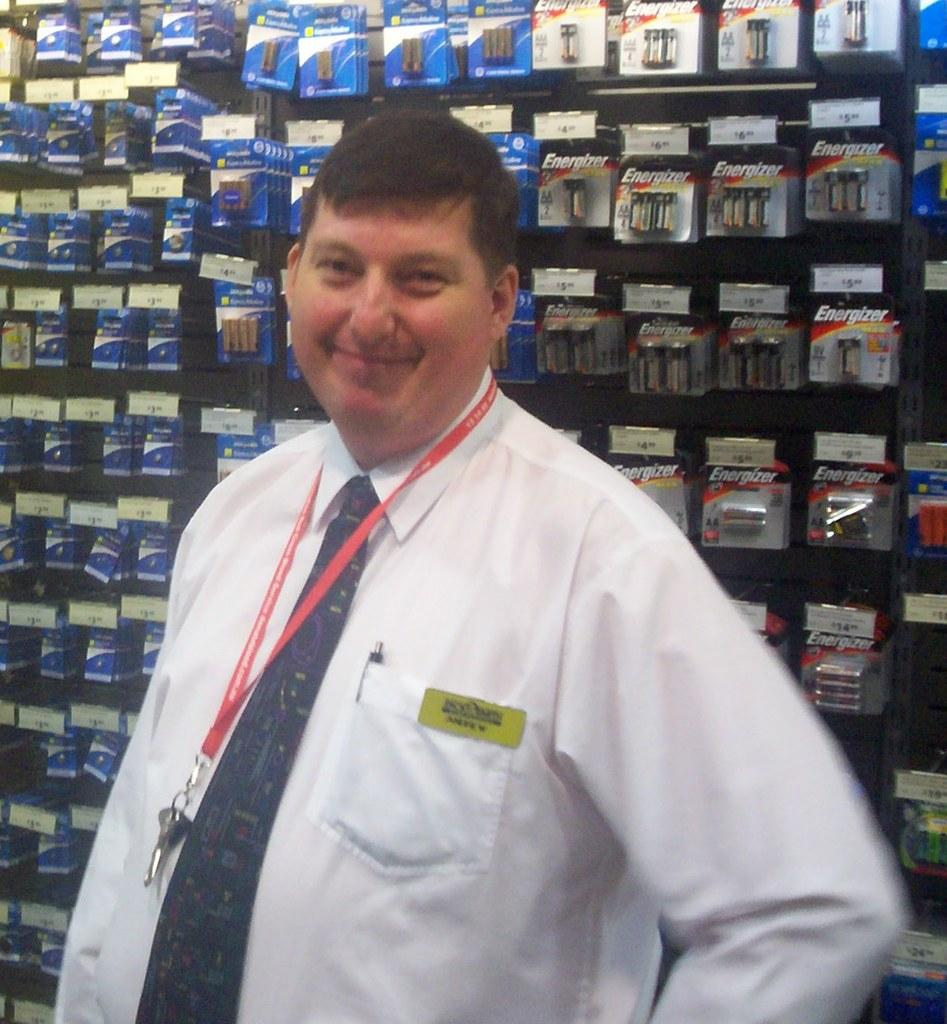<image>
Offer a succinct explanation of the picture presented. One of the main batteries on the wall is Energizer. 